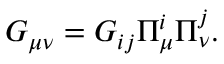Convert formula to latex. <formula><loc_0><loc_0><loc_500><loc_500>G _ { \mu \nu } = G _ { i j } \Pi _ { \mu } ^ { i } \Pi _ { \nu } ^ { j } .</formula> 